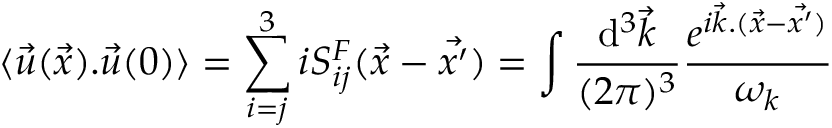Convert formula to latex. <formula><loc_0><loc_0><loc_500><loc_500>\langle { \vec { u } } ( \vec { x } ) . { \vec { u } } ( 0 ) \rangle = \sum _ { i = j } ^ { 3 } i S _ { i j } ^ { F } ( { \vec { x } } - { \vec { x ^ { \prime } } } ) = \int { \frac { d ^ { 3 } { \vec { k } } } { ( 2 \pi ) ^ { 3 } } } { { \frac { e ^ { i { \vec { k } } . ( { \vec { x } } - { \vec { x ^ { \prime } } ) } } } { \omega _ { k } } } }</formula> 